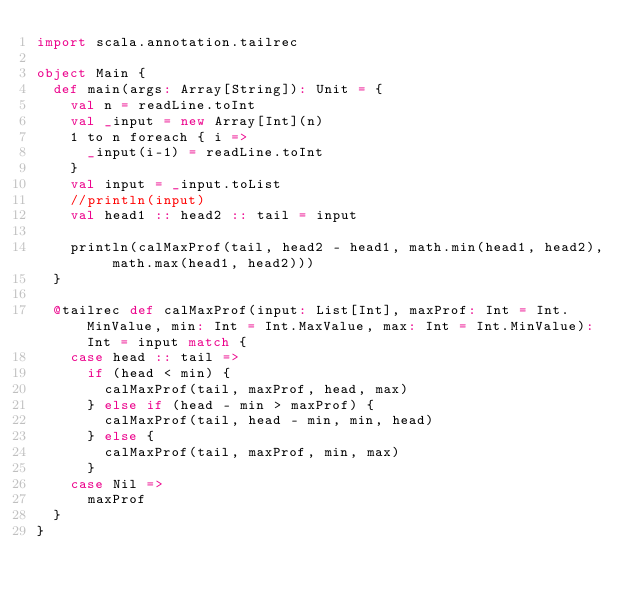<code> <loc_0><loc_0><loc_500><loc_500><_Scala_>import scala.annotation.tailrec

object Main {
  def main(args: Array[String]): Unit = {
    val n = readLine.toInt
    val _input = new Array[Int](n)
    1 to n foreach { i =>
      _input(i-1) = readLine.toInt
    }
    val input = _input.toList
    //println(input)
    val head1 :: head2 :: tail = input

    println(calMaxProf(tail, head2 - head1, math.min(head1, head2), math.max(head1, head2)))
  }

  @tailrec def calMaxProf(input: List[Int], maxProf: Int = Int.MinValue, min: Int = Int.MaxValue, max: Int = Int.MinValue): Int = input match {
    case head :: tail =>
      if (head < min) {
        calMaxProf(tail, maxProf, head, max)
      } else if (head - min > maxProf) {
        calMaxProf(tail, head - min, min, head)
      } else {
        calMaxProf(tail, maxProf, min, max)
      }
    case Nil =>
      maxProf
  }
}

</code> 